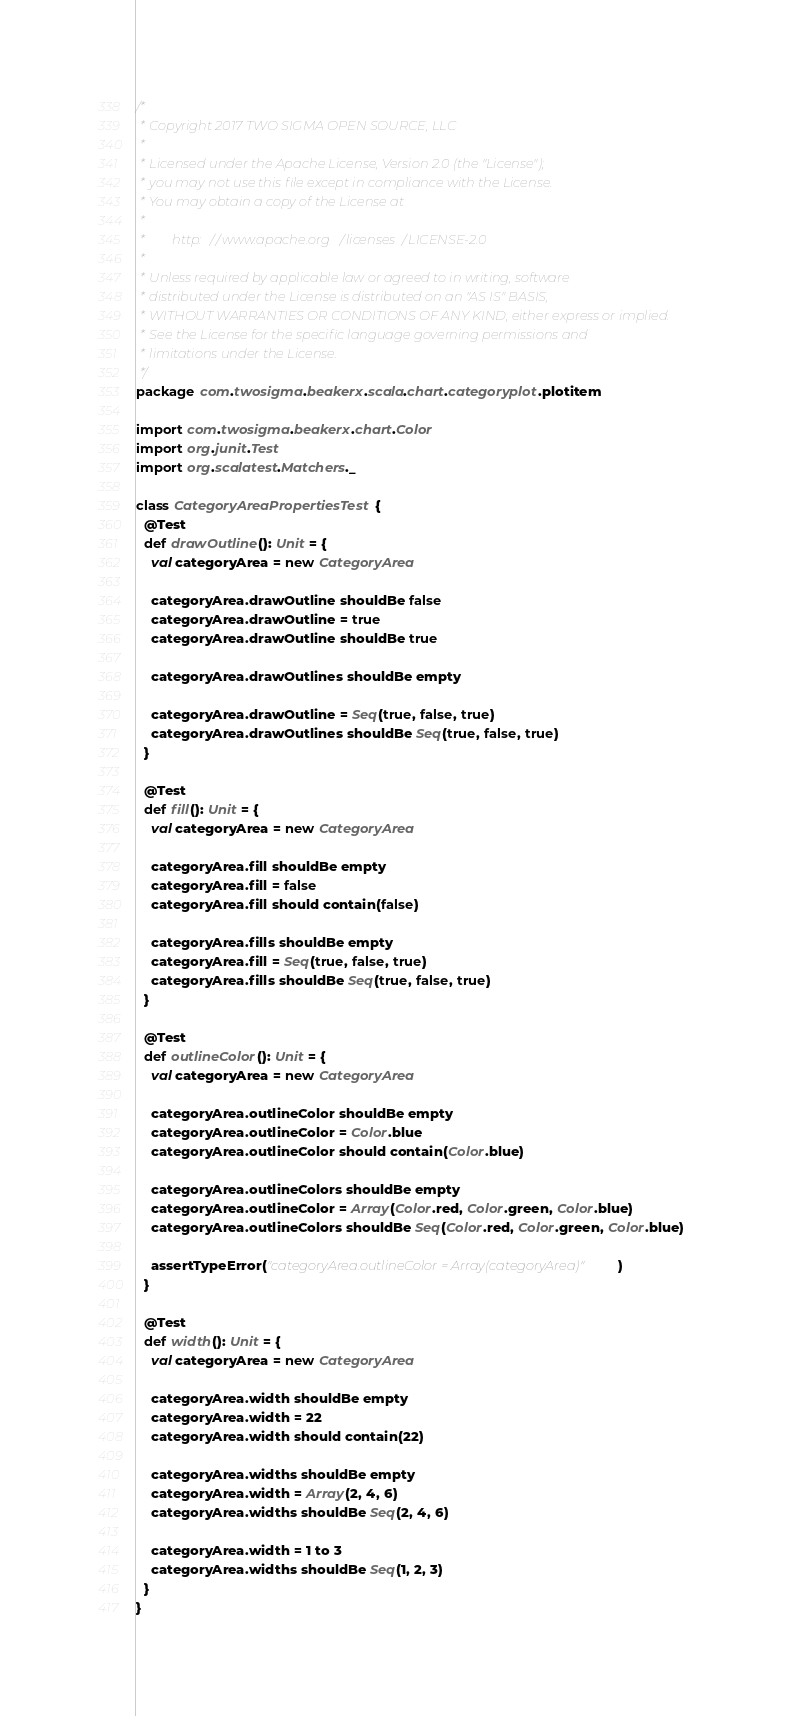Convert code to text. <code><loc_0><loc_0><loc_500><loc_500><_Scala_>/*
 * Copyright 2017 TWO SIGMA OPEN SOURCE, LLC
 *
 * Licensed under the Apache License, Version 2.0 (the "License");
 * you may not use this file except in compliance with the License.
 * You may obtain a copy of the License at
 *
 *        http://www.apache.org/licenses/LICENSE-2.0
 *
 * Unless required by applicable law or agreed to in writing, software
 * distributed under the License is distributed on an "AS IS" BASIS,
 * WITHOUT WARRANTIES OR CONDITIONS OF ANY KIND, either express or implied.
 * See the License for the specific language governing permissions and
 * limitations under the License.
 */
package com.twosigma.beakerx.scala.chart.categoryplot.plotitem

import com.twosigma.beakerx.chart.Color
import org.junit.Test
import org.scalatest.Matchers._

class CategoryAreaPropertiesTest {
  @Test
  def drawOutline(): Unit = {
    val categoryArea = new CategoryArea

    categoryArea.drawOutline shouldBe false
    categoryArea.drawOutline = true
    categoryArea.drawOutline shouldBe true

    categoryArea.drawOutlines shouldBe empty

    categoryArea.drawOutline = Seq(true, false, true)
    categoryArea.drawOutlines shouldBe Seq(true, false, true)
  }

  @Test
  def fill(): Unit = {
    val categoryArea = new CategoryArea

    categoryArea.fill shouldBe empty
    categoryArea.fill = false
    categoryArea.fill should contain(false)

    categoryArea.fills shouldBe empty
    categoryArea.fill = Seq(true, false, true)
    categoryArea.fills shouldBe Seq(true, false, true)
  }

  @Test
  def outlineColor(): Unit = {
    val categoryArea = new CategoryArea

    categoryArea.outlineColor shouldBe empty
    categoryArea.outlineColor = Color.blue
    categoryArea.outlineColor should contain(Color.blue)

    categoryArea.outlineColors shouldBe empty
    categoryArea.outlineColor = Array(Color.red, Color.green, Color.blue)
    categoryArea.outlineColors shouldBe Seq(Color.red, Color.green, Color.blue)

    assertTypeError("categoryArea.outlineColor = Array(categoryArea)")
  }

  @Test
  def width(): Unit = {
    val categoryArea = new CategoryArea

    categoryArea.width shouldBe empty
    categoryArea.width = 22
    categoryArea.width should contain(22)

    categoryArea.widths shouldBe empty
    categoryArea.width = Array(2, 4, 6)
    categoryArea.widths shouldBe Seq(2, 4, 6)

    categoryArea.width = 1 to 3
    categoryArea.widths shouldBe Seq(1, 2, 3)
  }
}
</code> 